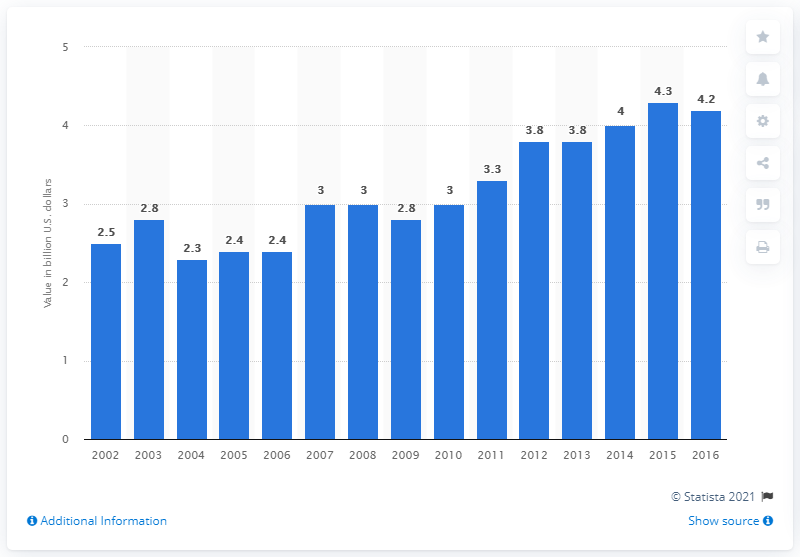Specify some key components in this picture. The value of U.S. product shipments of dried and dehydrated fruits and vegetables in 2016 was $4.2 billion. 